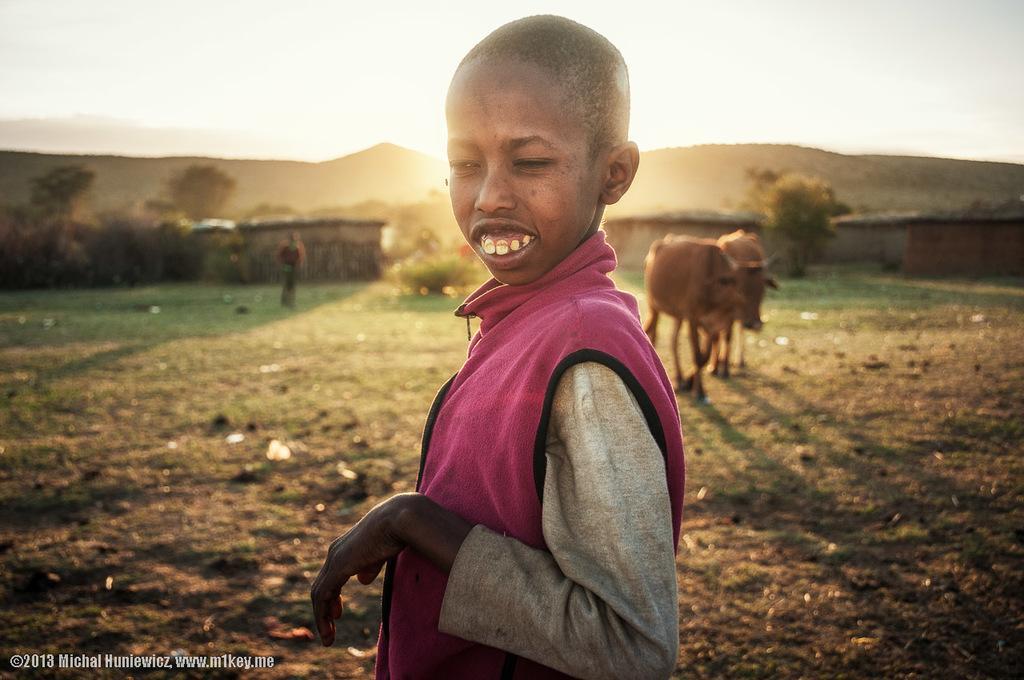Can you describe this image briefly? In this image we can see there are people, animals, trees and plants. In the background we can see the sky. In the bottom left corner there is a watermark. 